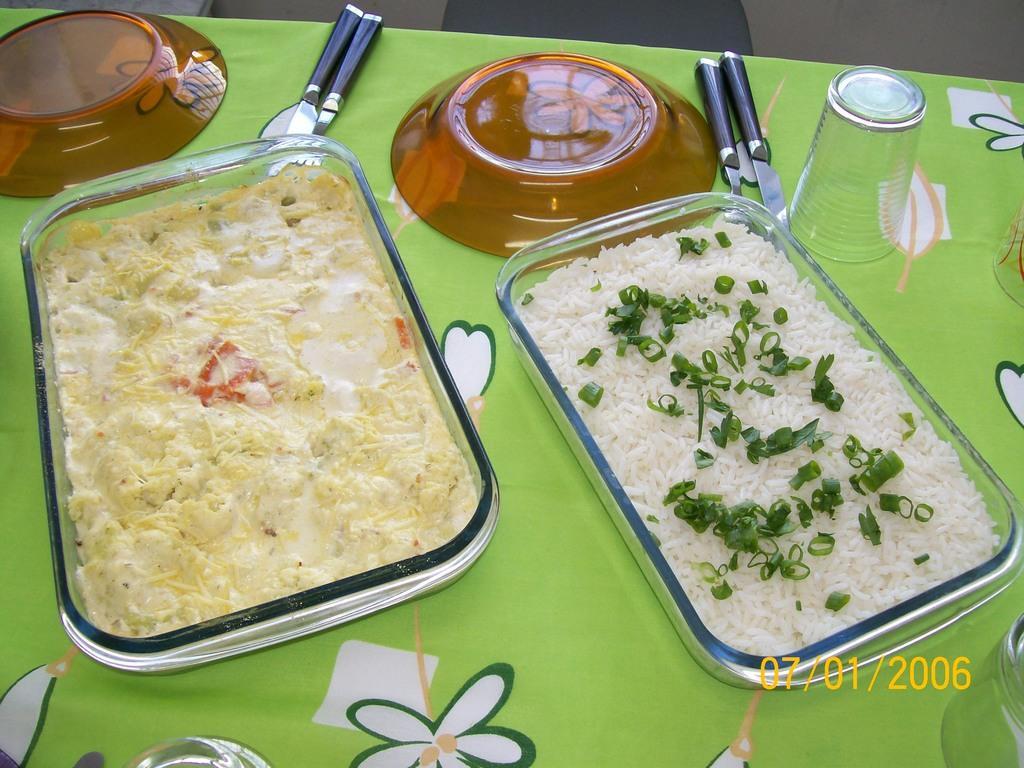Could you give a brief overview of what you see in this image? In this image we can see rice in a bowl, beside the rice bowl there is another bowl with some food item in it. The two bowls are placed on top of a table and there are two plates, knives and spoons and a glass as well. 